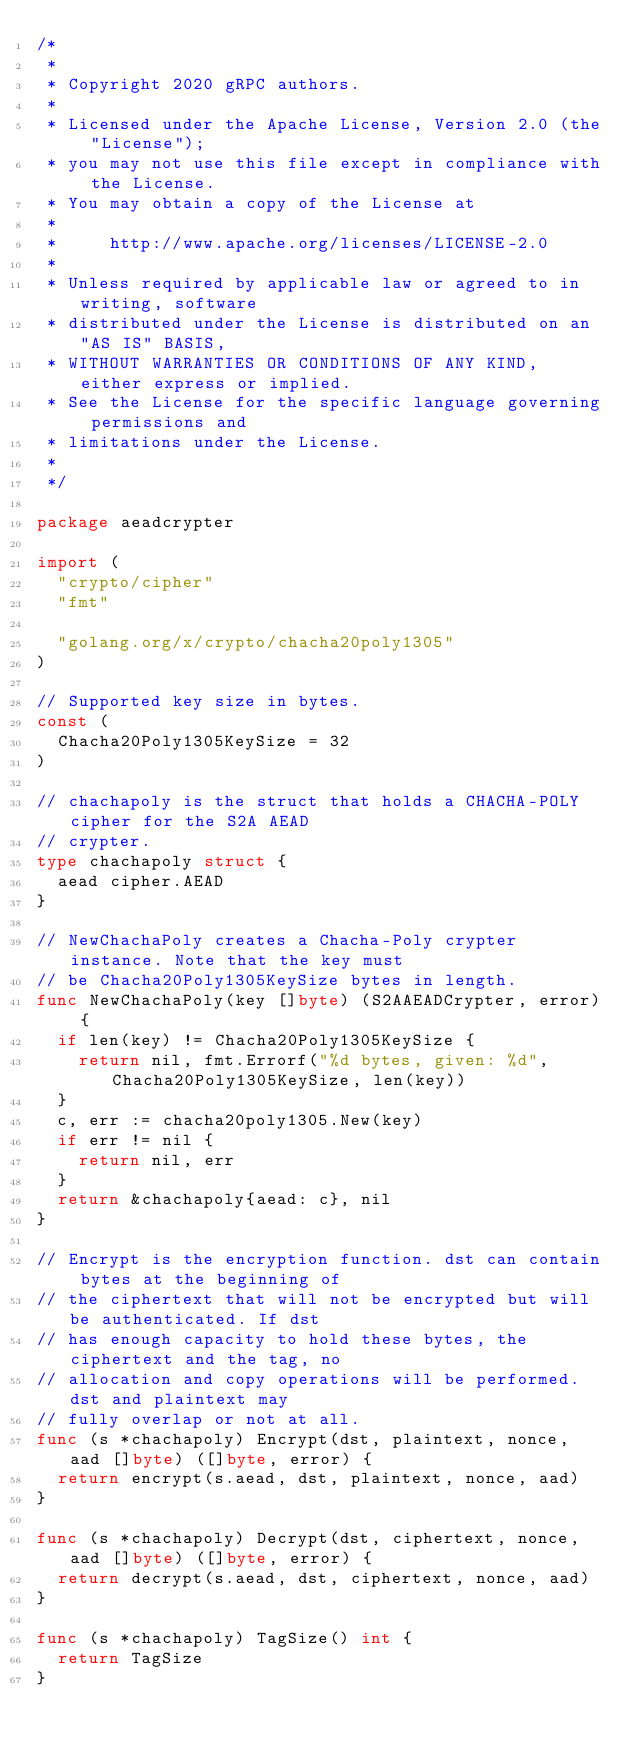Convert code to text. <code><loc_0><loc_0><loc_500><loc_500><_Go_>/*
 *
 * Copyright 2020 gRPC authors.
 *
 * Licensed under the Apache License, Version 2.0 (the "License");
 * you may not use this file except in compliance with the License.
 * You may obtain a copy of the License at
 *
 *     http://www.apache.org/licenses/LICENSE-2.0
 *
 * Unless required by applicable law or agreed to in writing, software
 * distributed under the License is distributed on an "AS IS" BASIS,
 * WITHOUT WARRANTIES OR CONDITIONS OF ANY KIND, either express or implied.
 * See the License for the specific language governing permissions and
 * limitations under the License.
 *
 */

package aeadcrypter

import (
	"crypto/cipher"
	"fmt"

	"golang.org/x/crypto/chacha20poly1305"
)

// Supported key size in bytes.
const (
	Chacha20Poly1305KeySize = 32
)

// chachapoly is the struct that holds a CHACHA-POLY cipher for the S2A AEAD
// crypter.
type chachapoly struct {
	aead cipher.AEAD
}

// NewChachaPoly creates a Chacha-Poly crypter instance. Note that the key must
// be Chacha20Poly1305KeySize bytes in length.
func NewChachaPoly(key []byte) (S2AAEADCrypter, error) {
	if len(key) != Chacha20Poly1305KeySize {
		return nil, fmt.Errorf("%d bytes, given: %d", Chacha20Poly1305KeySize, len(key))
	}
	c, err := chacha20poly1305.New(key)
	if err != nil {
		return nil, err
	}
	return &chachapoly{aead: c}, nil
}

// Encrypt is the encryption function. dst can contain bytes at the beginning of
// the ciphertext that will not be encrypted but will be authenticated. If dst
// has enough capacity to hold these bytes, the ciphertext and the tag, no
// allocation and copy operations will be performed. dst and plaintext may
// fully overlap or not at all.
func (s *chachapoly) Encrypt(dst, plaintext, nonce, aad []byte) ([]byte, error) {
	return encrypt(s.aead, dst, plaintext, nonce, aad)
}

func (s *chachapoly) Decrypt(dst, ciphertext, nonce, aad []byte) ([]byte, error) {
	return decrypt(s.aead, dst, ciphertext, nonce, aad)
}

func (s *chachapoly) TagSize() int {
	return TagSize
}
</code> 